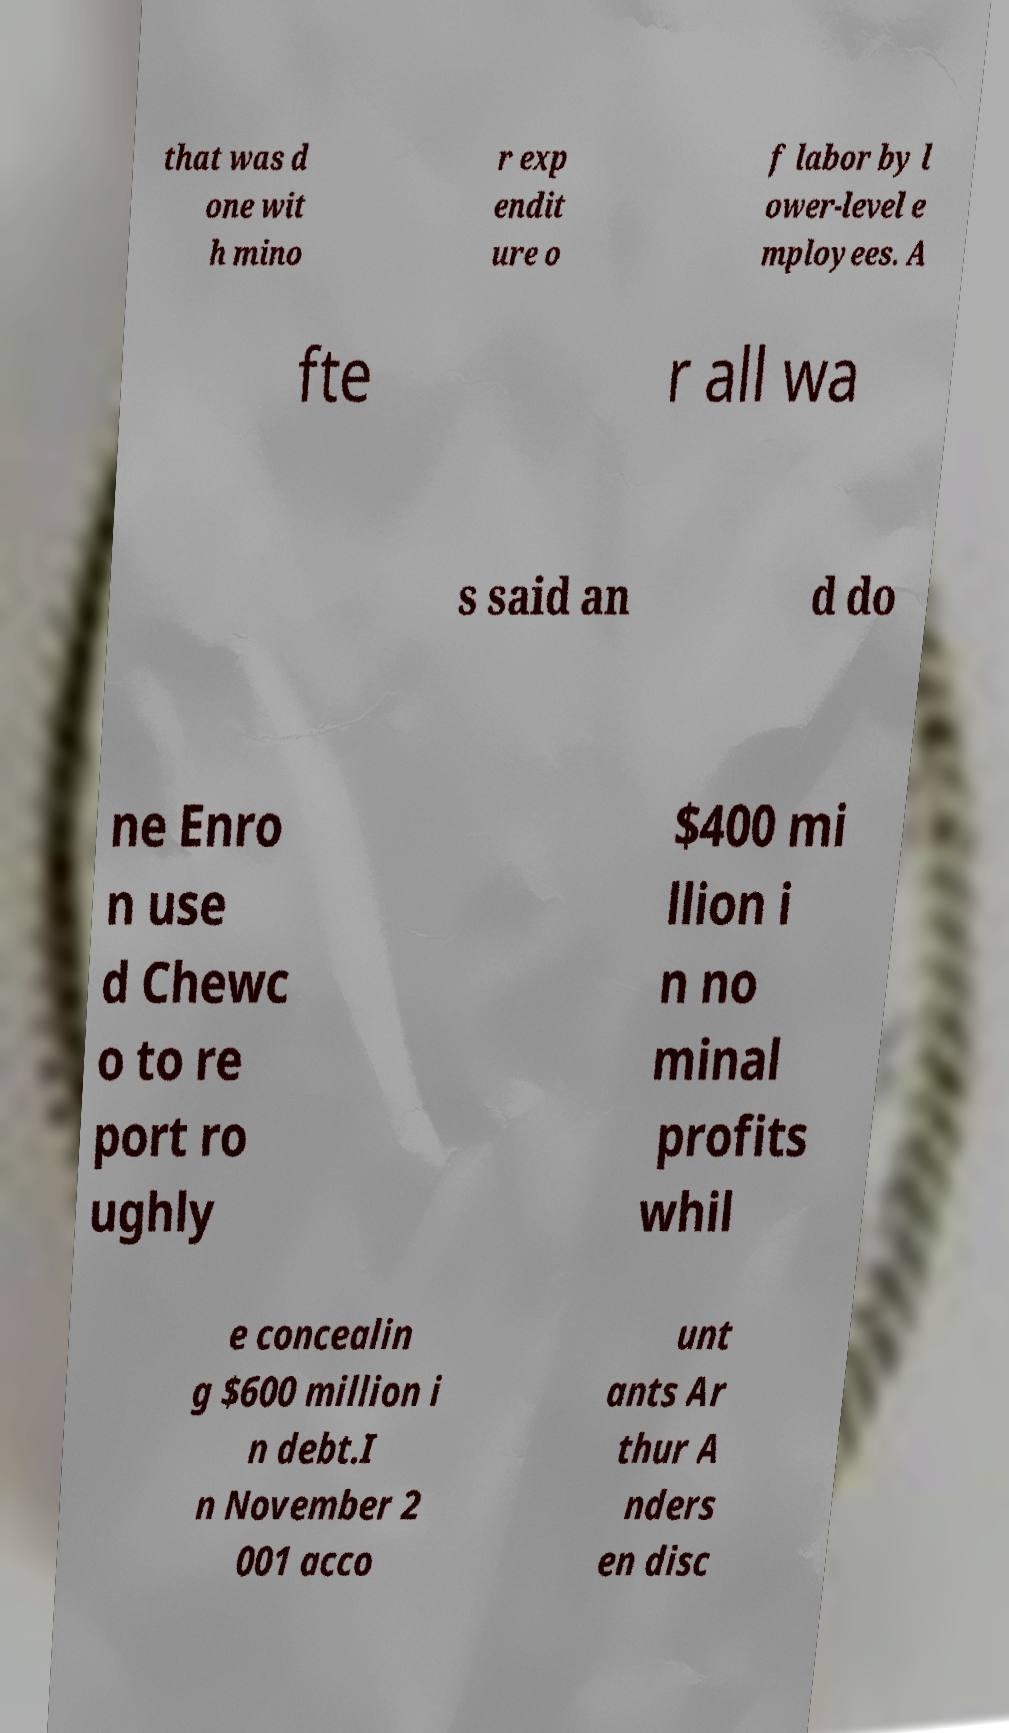I need the written content from this picture converted into text. Can you do that? that was d one wit h mino r exp endit ure o f labor by l ower-level e mployees. A fte r all wa s said an d do ne Enro n use d Chewc o to re port ro ughly $400 mi llion i n no minal profits whil e concealin g $600 million i n debt.I n November 2 001 acco unt ants Ar thur A nders en disc 